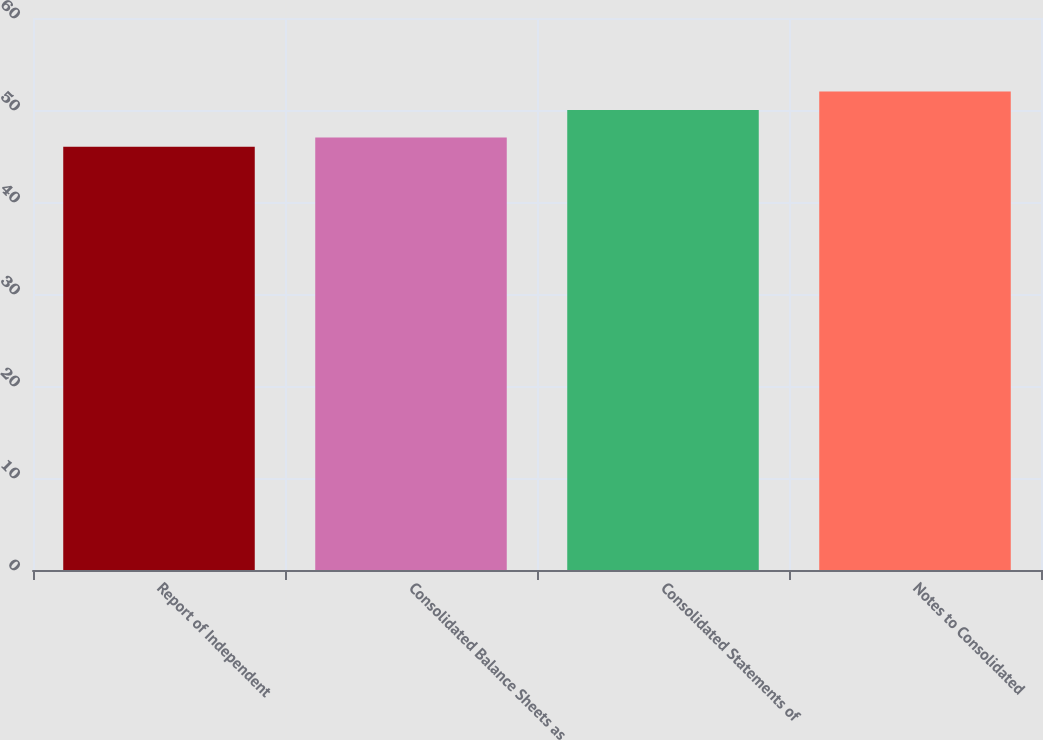<chart> <loc_0><loc_0><loc_500><loc_500><bar_chart><fcel>Report of Independent<fcel>Consolidated Balance Sheets as<fcel>Consolidated Statements of<fcel>Notes to Consolidated<nl><fcel>46<fcel>47<fcel>50<fcel>52<nl></chart> 